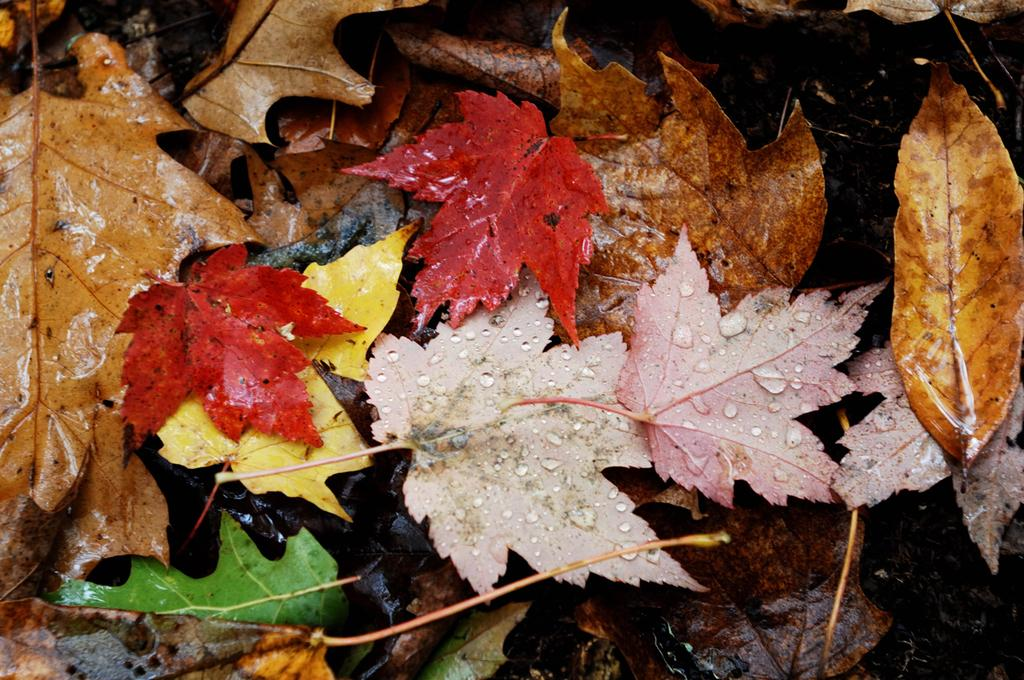What is on the ground in the image? There are leaves on the ground in the image. What colors can be seen in the leaves? The leaves have various colors, including brown, red, pink, green, and yellow. How does the army use the leaves in the image? There is no army present in the image, and therefore no such interaction can be observed. 